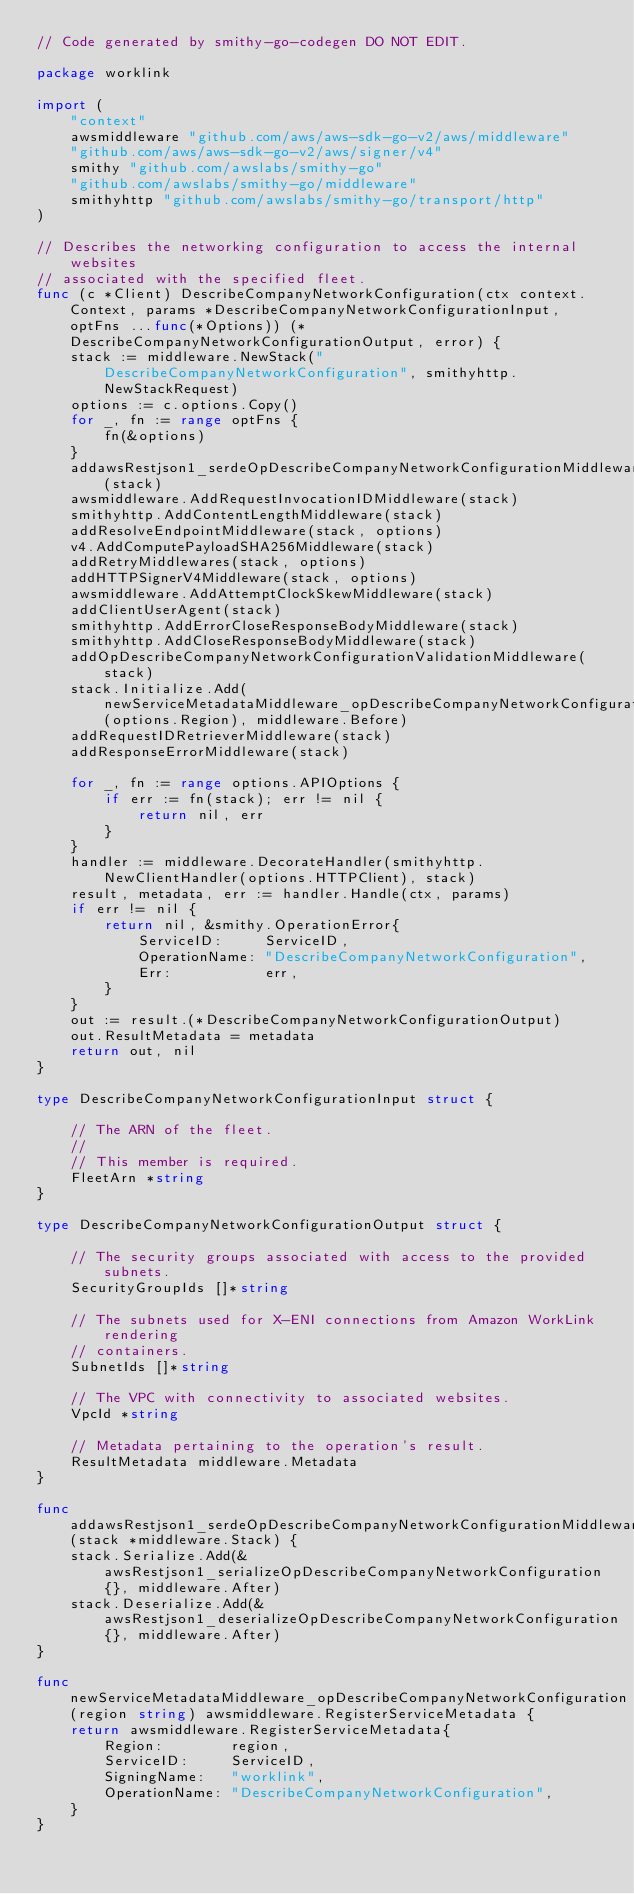Convert code to text. <code><loc_0><loc_0><loc_500><loc_500><_Go_>// Code generated by smithy-go-codegen DO NOT EDIT.

package worklink

import (
	"context"
	awsmiddleware "github.com/aws/aws-sdk-go-v2/aws/middleware"
	"github.com/aws/aws-sdk-go-v2/aws/signer/v4"
	smithy "github.com/awslabs/smithy-go"
	"github.com/awslabs/smithy-go/middleware"
	smithyhttp "github.com/awslabs/smithy-go/transport/http"
)

// Describes the networking configuration to access the internal websites
// associated with the specified fleet.
func (c *Client) DescribeCompanyNetworkConfiguration(ctx context.Context, params *DescribeCompanyNetworkConfigurationInput, optFns ...func(*Options)) (*DescribeCompanyNetworkConfigurationOutput, error) {
	stack := middleware.NewStack("DescribeCompanyNetworkConfiguration", smithyhttp.NewStackRequest)
	options := c.options.Copy()
	for _, fn := range optFns {
		fn(&options)
	}
	addawsRestjson1_serdeOpDescribeCompanyNetworkConfigurationMiddlewares(stack)
	awsmiddleware.AddRequestInvocationIDMiddleware(stack)
	smithyhttp.AddContentLengthMiddleware(stack)
	addResolveEndpointMiddleware(stack, options)
	v4.AddComputePayloadSHA256Middleware(stack)
	addRetryMiddlewares(stack, options)
	addHTTPSignerV4Middleware(stack, options)
	awsmiddleware.AddAttemptClockSkewMiddleware(stack)
	addClientUserAgent(stack)
	smithyhttp.AddErrorCloseResponseBodyMiddleware(stack)
	smithyhttp.AddCloseResponseBodyMiddleware(stack)
	addOpDescribeCompanyNetworkConfigurationValidationMiddleware(stack)
	stack.Initialize.Add(newServiceMetadataMiddleware_opDescribeCompanyNetworkConfiguration(options.Region), middleware.Before)
	addRequestIDRetrieverMiddleware(stack)
	addResponseErrorMiddleware(stack)

	for _, fn := range options.APIOptions {
		if err := fn(stack); err != nil {
			return nil, err
		}
	}
	handler := middleware.DecorateHandler(smithyhttp.NewClientHandler(options.HTTPClient), stack)
	result, metadata, err := handler.Handle(ctx, params)
	if err != nil {
		return nil, &smithy.OperationError{
			ServiceID:     ServiceID,
			OperationName: "DescribeCompanyNetworkConfiguration",
			Err:           err,
		}
	}
	out := result.(*DescribeCompanyNetworkConfigurationOutput)
	out.ResultMetadata = metadata
	return out, nil
}

type DescribeCompanyNetworkConfigurationInput struct {

	// The ARN of the fleet.
	//
	// This member is required.
	FleetArn *string
}

type DescribeCompanyNetworkConfigurationOutput struct {

	// The security groups associated with access to the provided subnets.
	SecurityGroupIds []*string

	// The subnets used for X-ENI connections from Amazon WorkLink rendering
	// containers.
	SubnetIds []*string

	// The VPC with connectivity to associated websites.
	VpcId *string

	// Metadata pertaining to the operation's result.
	ResultMetadata middleware.Metadata
}

func addawsRestjson1_serdeOpDescribeCompanyNetworkConfigurationMiddlewares(stack *middleware.Stack) {
	stack.Serialize.Add(&awsRestjson1_serializeOpDescribeCompanyNetworkConfiguration{}, middleware.After)
	stack.Deserialize.Add(&awsRestjson1_deserializeOpDescribeCompanyNetworkConfiguration{}, middleware.After)
}

func newServiceMetadataMiddleware_opDescribeCompanyNetworkConfiguration(region string) awsmiddleware.RegisterServiceMetadata {
	return awsmiddleware.RegisterServiceMetadata{
		Region:        region,
		ServiceID:     ServiceID,
		SigningName:   "worklink",
		OperationName: "DescribeCompanyNetworkConfiguration",
	}
}
</code> 